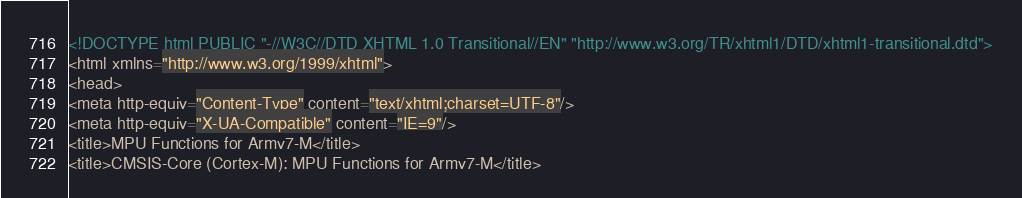<code> <loc_0><loc_0><loc_500><loc_500><_HTML_><!DOCTYPE html PUBLIC "-//W3C//DTD XHTML 1.0 Transitional//EN" "http://www.w3.org/TR/xhtml1/DTD/xhtml1-transitional.dtd">
<html xmlns="http://www.w3.org/1999/xhtml">
<head>
<meta http-equiv="Content-Type" content="text/xhtml;charset=UTF-8"/>
<meta http-equiv="X-UA-Compatible" content="IE=9"/>
<title>MPU Functions for Armv7-M</title>
<title>CMSIS-Core (Cortex-M): MPU Functions for Armv7-M</title></code> 